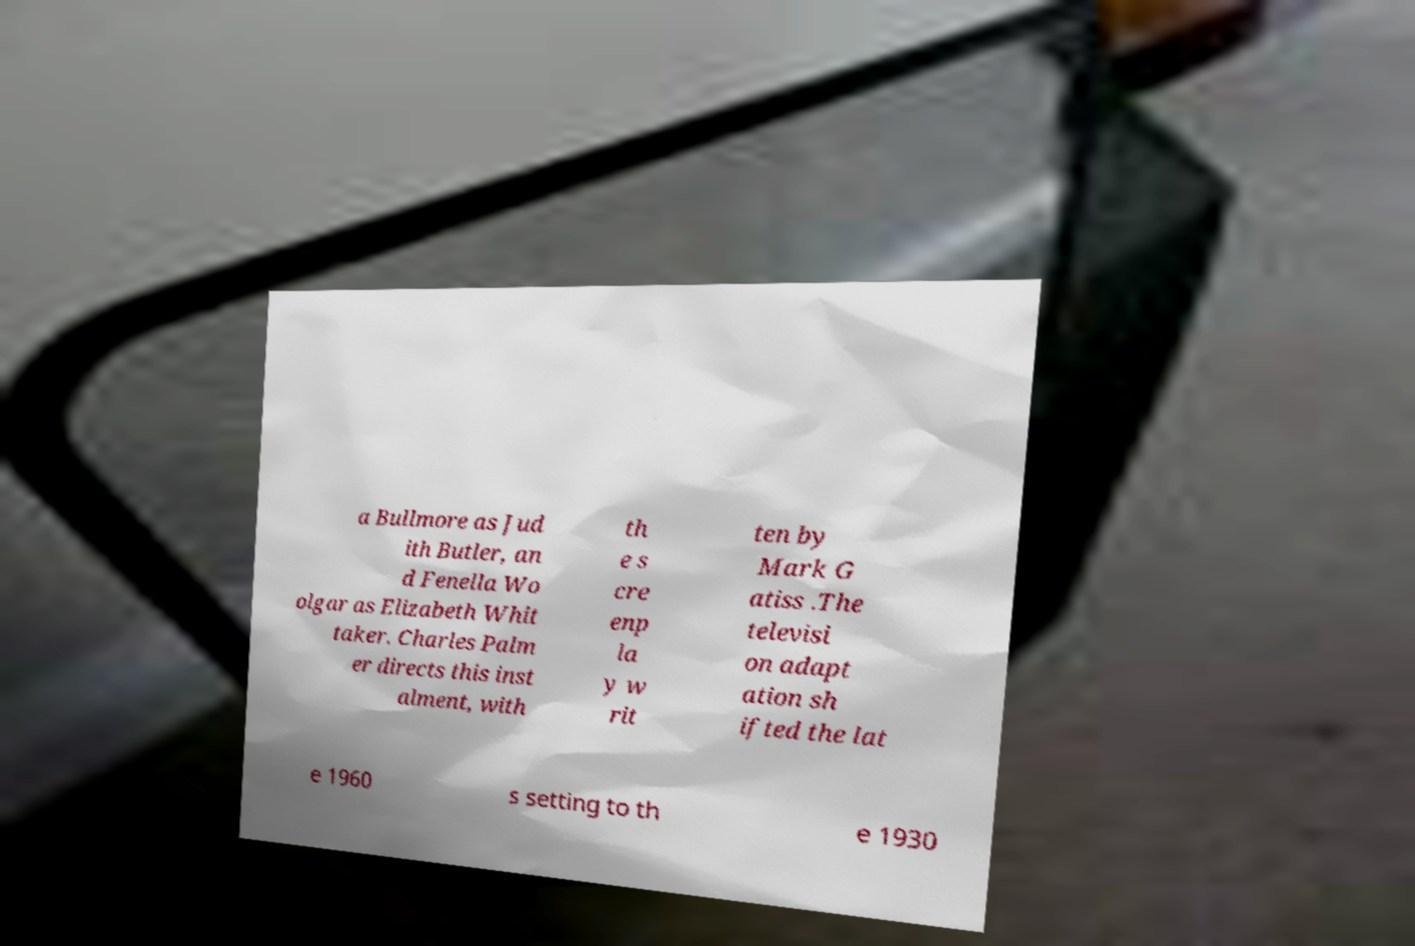Please read and relay the text visible in this image. What does it say? a Bullmore as Jud ith Butler, an d Fenella Wo olgar as Elizabeth Whit taker. Charles Palm er directs this inst alment, with th e s cre enp la y w rit ten by Mark G atiss .The televisi on adapt ation sh ifted the lat e 1960 s setting to th e 1930 